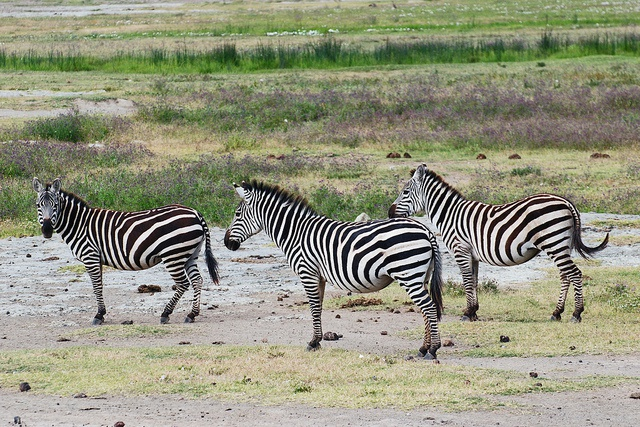Describe the objects in this image and their specific colors. I can see zebra in darkgray, black, lightgray, and gray tones, zebra in darkgray, black, lightgray, and gray tones, and zebra in darkgray, black, lightgray, and gray tones in this image. 